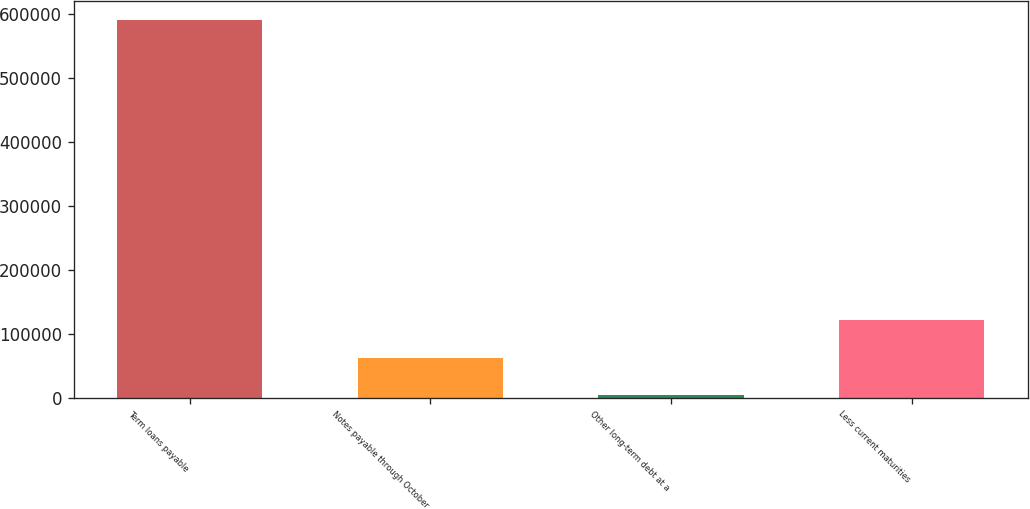<chart> <loc_0><loc_0><loc_500><loc_500><bar_chart><fcel>Term loans payable<fcel>Notes payable through October<fcel>Other long-term debt at a<fcel>Less current maturities<nl><fcel>590099<fcel>62597.3<fcel>3986<fcel>121209<nl></chart> 